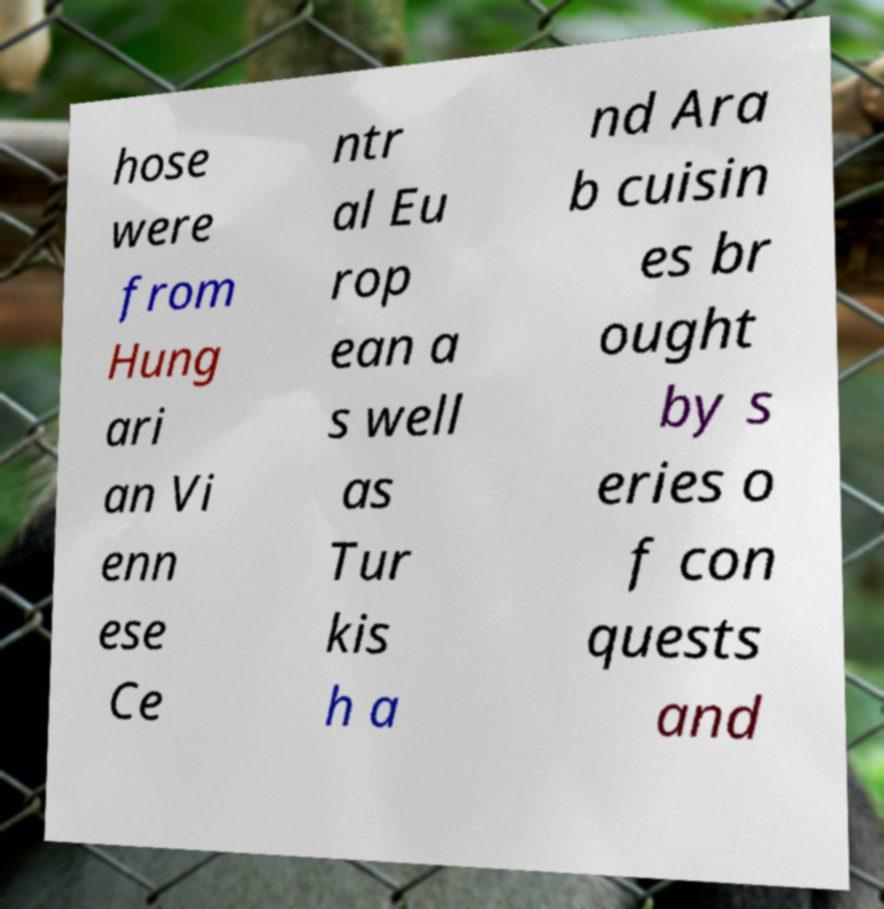For documentation purposes, I need the text within this image transcribed. Could you provide that? hose were from Hung ari an Vi enn ese Ce ntr al Eu rop ean a s well as Tur kis h a nd Ara b cuisin es br ought by s eries o f con quests and 